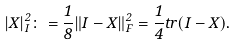Convert formula to latex. <formula><loc_0><loc_0><loc_500><loc_500>| X | _ { I } ^ { 2 } \colon = \frac { 1 } { 8 } \| I - X \| _ { F } ^ { 2 } = \frac { 1 } { 4 } t r ( I - X ) .</formula> 